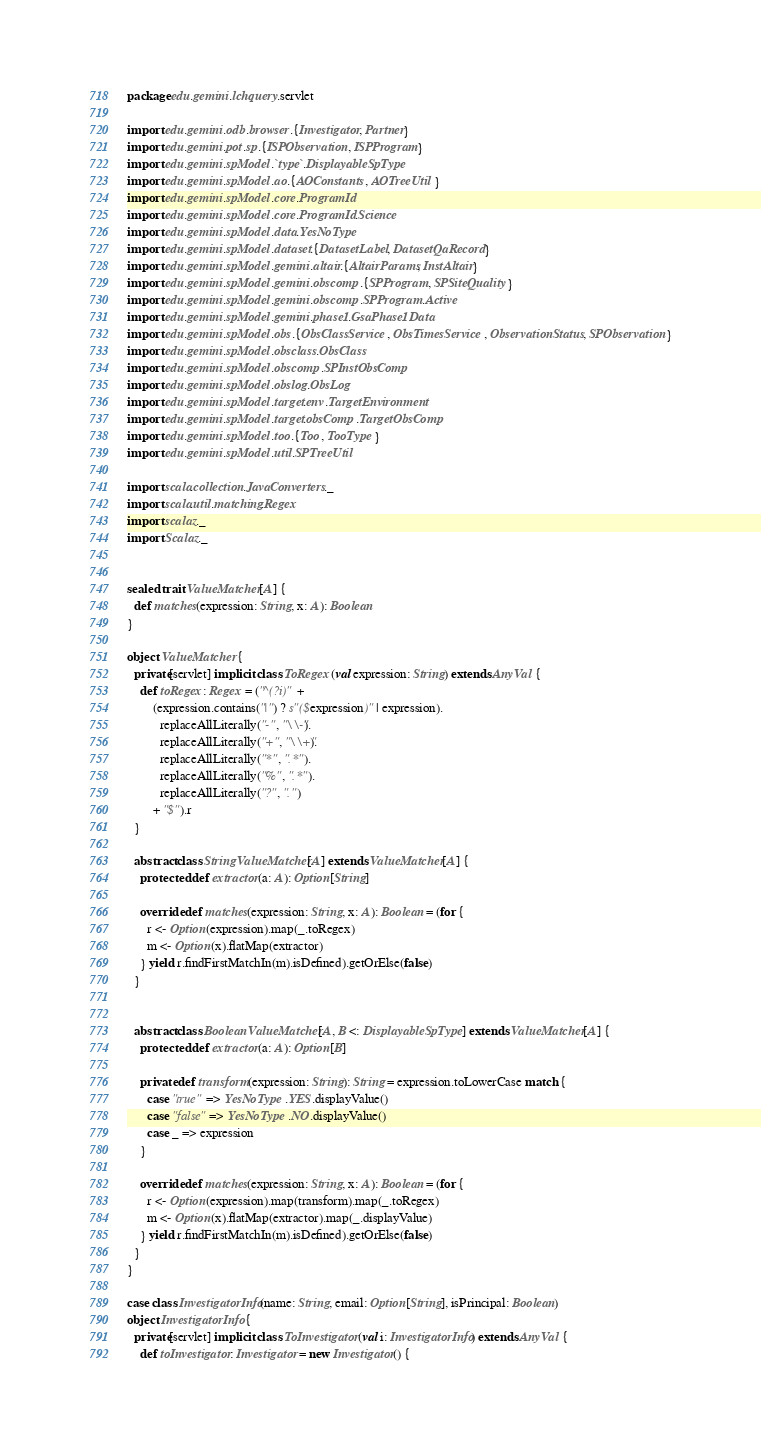Convert code to text. <code><loc_0><loc_0><loc_500><loc_500><_Scala_>package edu.gemini.lchquery.servlet

import edu.gemini.odb.browser.{Investigator, Partner}
import edu.gemini.pot.sp.{ISPObservation, ISPProgram}
import edu.gemini.spModel.`type`.DisplayableSpType
import edu.gemini.spModel.ao.{AOConstants, AOTreeUtil}
import edu.gemini.spModel.core.ProgramId
import edu.gemini.spModel.core.ProgramId.Science
import edu.gemini.spModel.data.YesNoType
import edu.gemini.spModel.dataset.{DatasetLabel, DatasetQaRecord}
import edu.gemini.spModel.gemini.altair.{AltairParams, InstAltair}
import edu.gemini.spModel.gemini.obscomp.{SPProgram, SPSiteQuality}
import edu.gemini.spModel.gemini.obscomp.SPProgram.Active
import edu.gemini.spModel.gemini.phase1.GsaPhase1Data
import edu.gemini.spModel.obs.{ObsClassService, ObsTimesService, ObservationStatus, SPObservation}
import edu.gemini.spModel.obsclass.ObsClass
import edu.gemini.spModel.obscomp.SPInstObsComp
import edu.gemini.spModel.obslog.ObsLog
import edu.gemini.spModel.target.env.TargetEnvironment
import edu.gemini.spModel.target.obsComp.TargetObsComp
import edu.gemini.spModel.too.{Too, TooType}
import edu.gemini.spModel.util.SPTreeUtil

import scala.collection.JavaConverters._
import scala.util.matching.Regex
import scalaz._
import Scalaz._


sealed trait ValueMatcher[A] {
  def matches(expression: String, x: A): Boolean
}

object ValueMatcher {
  private[servlet] implicit class ToRegex(val expression: String) extends AnyVal {
    def toRegex: Regex = ("^(?i)" +
        (expression.contains("|") ? s"($expression)" | expression).
          replaceAllLiterally("-", "\\-").
          replaceAllLiterally("+", "\\+").
          replaceAllLiterally("*", ".*").
          replaceAllLiterally("%", ".*").
          replaceAllLiterally("?", ".")
        + "$").r
  }

  abstract class StringValueMatcher[A] extends ValueMatcher[A] {
    protected def extractor(a: A): Option[String]

    override def matches(expression: String, x: A): Boolean = (for {
      r <- Option(expression).map(_.toRegex)
      m <- Option(x).flatMap(extractor)
    } yield r.findFirstMatchIn(m).isDefined).getOrElse(false)
  }


  abstract class BooleanValueMatcher[A, B <: DisplayableSpType] extends ValueMatcher[A] {
    protected def extractor(a: A): Option[B]

    private def transform(expression: String): String = expression.toLowerCase match {
      case "true" => YesNoType.YES.displayValue()
      case "false" => YesNoType.NO.displayValue()
      case _ => expression
    }

    override def matches(expression: String, x: A): Boolean = (for {
      r <- Option(expression).map(transform).map(_.toRegex)
      m <- Option(x).flatMap(extractor).map(_.displayValue)
    } yield r.findFirstMatchIn(m).isDefined).getOrElse(false)
  }
}

case class InvestigatorInfo(name: String, email: Option[String], isPrincipal: Boolean)
object InvestigatorInfo {
  private[servlet] implicit class ToInvestigator(val i: InvestigatorInfo) extends AnyVal {
    def toInvestigator: Investigator = new Investigator() {</code> 